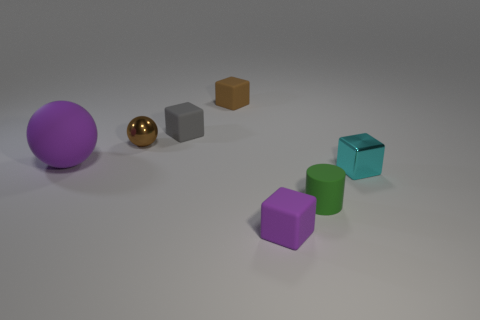What size is the ball that is the same material as the gray cube?
Your answer should be compact. Large. What number of tiny things have the same color as the big matte object?
Give a very brief answer. 1. How many tiny objects are purple spheres or brown shiny spheres?
Offer a terse response. 1. There is a rubber thing that is the same color as the matte ball; what is its size?
Keep it short and to the point. Small. Is there a small purple thing made of the same material as the green object?
Provide a succinct answer. Yes. There is a sphere that is on the right side of the purple rubber sphere; what material is it?
Keep it short and to the point. Metal. Does the small cube in front of the cyan metallic object have the same color as the large matte sphere that is behind the tiny purple matte object?
Provide a succinct answer. Yes. What is the color of the cylinder that is the same size as the cyan thing?
Your answer should be very brief. Green. How many other things are the same shape as the large purple thing?
Offer a very short reply. 1. How big is the matte sphere in front of the tiny brown matte thing?
Give a very brief answer. Large. 